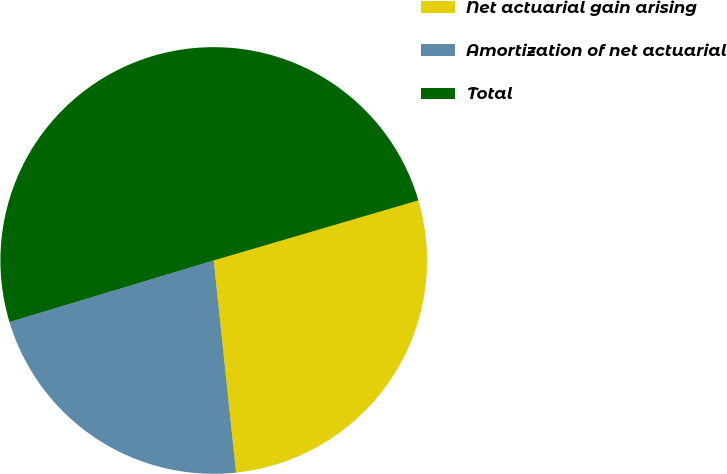Convert chart to OTSL. <chart><loc_0><loc_0><loc_500><loc_500><pie_chart><fcel>Net actuarial gain arising<fcel>Amortization of net actuarial<fcel>Total<nl><fcel>27.87%<fcel>22.0%<fcel>50.12%<nl></chart> 